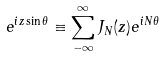<formula> <loc_0><loc_0><loc_500><loc_500>e ^ { i z \sin \theta } \equiv \sum _ { - \infty } ^ { \infty } J _ { N } ( z ) e ^ { i N \theta }</formula> 